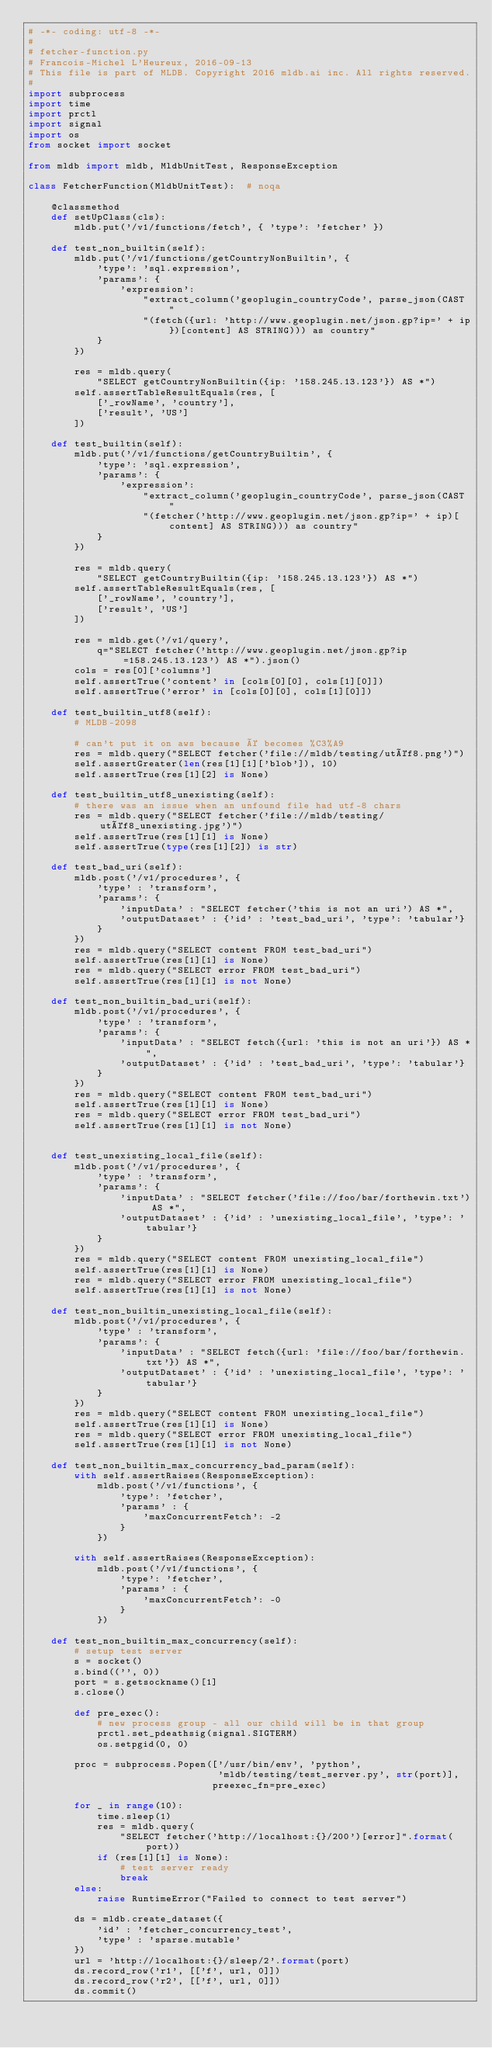<code> <loc_0><loc_0><loc_500><loc_500><_Python_># -*- coding: utf-8 -*-
#
# fetcher-function.py
# Francois-Michel L'Heureux, 2016-09-13
# This file is part of MLDB. Copyright 2016 mldb.ai inc. All rights reserved.
#
import subprocess
import time
import prctl
import signal
import os
from socket import socket

from mldb import mldb, MldbUnitTest, ResponseException

class FetcherFunction(MldbUnitTest):  # noqa

    @classmethod
    def setUpClass(cls):
        mldb.put('/v1/functions/fetch', { 'type': 'fetcher' })

    def test_non_builtin(self):
        mldb.put('/v1/functions/getCountryNonBuiltin', {
            'type': 'sql.expression',
            'params': {
                'expression':
                    "extract_column('geoplugin_countryCode', parse_json(CAST "
                    "(fetch({url: 'http://www.geoplugin.net/json.gp?ip=' + ip})[content] AS STRING))) as country"
            }
        })

        res = mldb.query(
            "SELECT getCountryNonBuiltin({ip: '158.245.13.123'}) AS *")
        self.assertTableResultEquals(res, [
            ['_rowName', 'country'],
            ['result', 'US']
        ])

    def test_builtin(self):
        mldb.put('/v1/functions/getCountryBuiltin', {
            'type': 'sql.expression',
            'params': {
                'expression':
                    "extract_column('geoplugin_countryCode', parse_json(CAST "
                    "(fetcher('http://www.geoplugin.net/json.gp?ip=' + ip)[content] AS STRING))) as country"
            }
        })

        res = mldb.query(
            "SELECT getCountryBuiltin({ip: '158.245.13.123'}) AS *")
        self.assertTableResultEquals(res, [
            ['_rowName', 'country'],
            ['result', 'US']
        ])

        res = mldb.get('/v1/query',
            q="SELECT fetcher('http://www.geoplugin.net/json.gp?ip=158.245.13.123') AS *").json()
        cols = res[0]['columns']
        self.assertTrue('content' in [cols[0][0], cols[1][0]])
        self.assertTrue('error' in [cols[0][0], cols[1][0]])

    def test_builtin_utf8(self):
        # MLDB-2098

        # can't put it on aws because é becomes %C3%A9
        res = mldb.query("SELECT fetcher('file://mldb/testing/utéf8.png')")
        self.assertGreater(len(res[1][1]['blob']), 10)
        self.assertTrue(res[1][2] is None)

    def test_builtin_utf8_unexisting(self):
        # there was an issue when an unfound file had utf-8 chars
        res = mldb.query("SELECT fetcher('file://mldb/testing/utéf8_unexisting.jpg')")
        self.assertTrue(res[1][1] is None)
        self.assertTrue(type(res[1][2]) is str)

    def test_bad_uri(self):
        mldb.post('/v1/procedures', {
            'type' : 'transform',
            'params': {
                'inputData' : "SELECT fetcher('this is not an uri') AS *",
                'outputDataset' : {'id' : 'test_bad_uri', 'type': 'tabular'}
            }
        })
        res = mldb.query("SELECT content FROM test_bad_uri")
        self.assertTrue(res[1][1] is None)
        res = mldb.query("SELECT error FROM test_bad_uri")
        self.assertTrue(res[1][1] is not None)

    def test_non_builtin_bad_uri(self):
        mldb.post('/v1/procedures', {
            'type' : 'transform',
            'params': {
                'inputData' : "SELECT fetch({url: 'this is not an uri'}) AS *",
                'outputDataset' : {'id' : 'test_bad_uri', 'type': 'tabular'}
            }
        })
        res = mldb.query("SELECT content FROM test_bad_uri")
        self.assertTrue(res[1][1] is None)
        res = mldb.query("SELECT error FROM test_bad_uri")
        self.assertTrue(res[1][1] is not None)


    def test_unexisting_local_file(self):
        mldb.post('/v1/procedures', {
            'type' : 'transform',
            'params': {
                'inputData' : "SELECT fetcher('file://foo/bar/forthewin.txt') AS *",
                'outputDataset' : {'id' : 'unexisting_local_file', 'type': 'tabular'}
            }
        })
        res = mldb.query("SELECT content FROM unexisting_local_file")
        self.assertTrue(res[1][1] is None)
        res = mldb.query("SELECT error FROM unexisting_local_file")
        self.assertTrue(res[1][1] is not None)

    def test_non_builtin_unexisting_local_file(self):
        mldb.post('/v1/procedures', {
            'type' : 'transform',
            'params': {
                'inputData' : "SELECT fetch({url: 'file://foo/bar/forthewin.txt'}) AS *",
                'outputDataset' : {'id' : 'unexisting_local_file', 'type': 'tabular'}
            }
        })
        res = mldb.query("SELECT content FROM unexisting_local_file")
        self.assertTrue(res[1][1] is None)
        res = mldb.query("SELECT error FROM unexisting_local_file")
        self.assertTrue(res[1][1] is not None)

    def test_non_builtin_max_concurrency_bad_param(self):
        with self.assertRaises(ResponseException):
            mldb.post('/v1/functions', {
                'type': 'fetcher',
                'params' : {
                    'maxConcurrentFetch': -2
                }
            })

        with self.assertRaises(ResponseException):
            mldb.post('/v1/functions', {
                'type': 'fetcher',
                'params' : {
                    'maxConcurrentFetch': -0
                }
            })

    def test_non_builtin_max_concurrency(self):
        # setup test server
        s = socket()
        s.bind(('', 0))
        port = s.getsockname()[1]
        s.close()

        def pre_exec():
            # new process group - all our child will be in that group
            prctl.set_pdeathsig(signal.SIGTERM)
            os.setpgid(0, 0)

        proc = subprocess.Popen(['/usr/bin/env', 'python',
                                 'mldb/testing/test_server.py', str(port)],
                                preexec_fn=pre_exec)

        for _ in range(10):
            time.sleep(1)
            res = mldb.query(
                "SELECT fetcher('http://localhost:{}/200')[error]".format(port))
            if (res[1][1] is None):
                # test server ready
                break
        else:
            raise RuntimeError("Failed to connect to test server")

        ds = mldb.create_dataset({
            'id' : 'fetcher_concurrency_test',
            'type' : 'sparse.mutable'
        })
        url = 'http://localhost:{}/sleep/2'.format(port)
        ds.record_row('r1', [['f', url, 0]])
        ds.record_row('r2', [['f', url, 0]])
        ds.commit()
</code> 